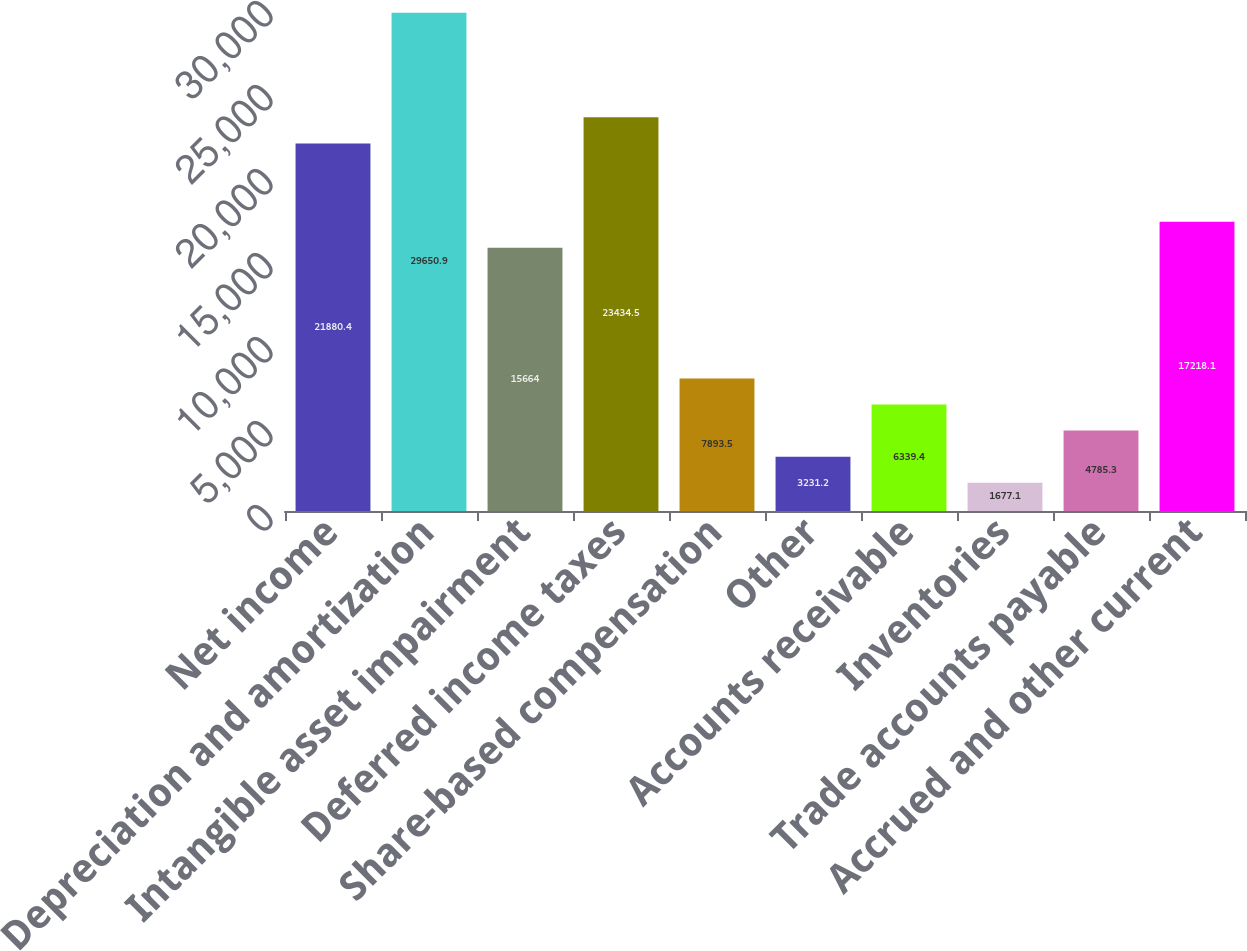<chart> <loc_0><loc_0><loc_500><loc_500><bar_chart><fcel>Net income<fcel>Depreciation and amortization<fcel>Intangible asset impairment<fcel>Deferred income taxes<fcel>Share-based compensation<fcel>Other<fcel>Accounts receivable<fcel>Inventories<fcel>Trade accounts payable<fcel>Accrued and other current<nl><fcel>21880.4<fcel>29650.9<fcel>15664<fcel>23434.5<fcel>7893.5<fcel>3231.2<fcel>6339.4<fcel>1677.1<fcel>4785.3<fcel>17218.1<nl></chart> 